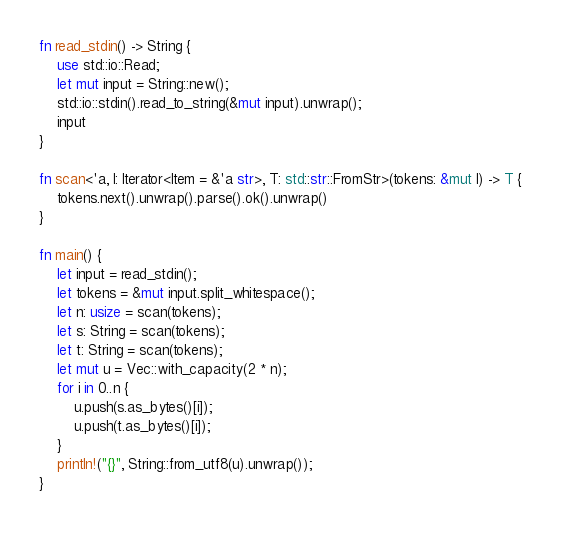<code> <loc_0><loc_0><loc_500><loc_500><_Rust_>fn read_stdin() -> String {
    use std::io::Read;
    let mut input = String::new();
    std::io::stdin().read_to_string(&mut input).unwrap();
    input
}

fn scan<'a, I: Iterator<Item = &'a str>, T: std::str::FromStr>(tokens: &mut I) -> T {
    tokens.next().unwrap().parse().ok().unwrap()
}

fn main() {
    let input = read_stdin();
    let tokens = &mut input.split_whitespace();
    let n: usize = scan(tokens);
    let s: String = scan(tokens);
    let t: String = scan(tokens);
    let mut u = Vec::with_capacity(2 * n);
    for i in 0..n {
        u.push(s.as_bytes()[i]);
        u.push(t.as_bytes()[i]);
    }
    println!("{}", String::from_utf8(u).unwrap());
}
</code> 